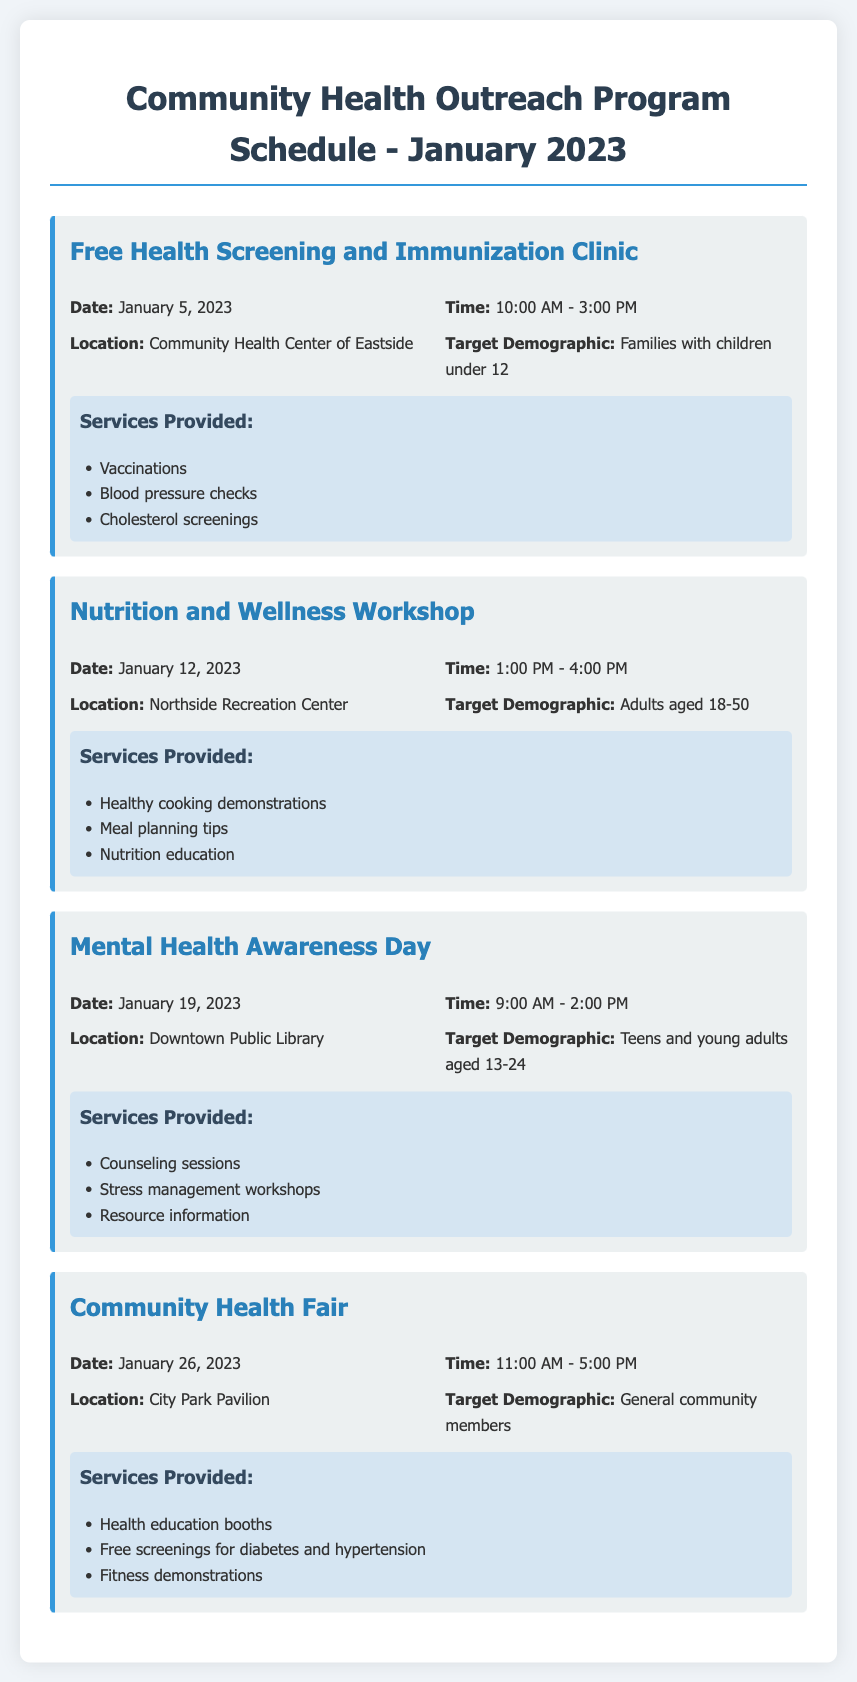What is the date of the Free Health Screening and Immunization Clinic? The date is mentioned in the schedule for the corresponding event, which is January 5, 2023.
Answer: January 5, 2023 What time does the Nutrition and Wellness Workshop start? The start time is specified under the event details for the Nutrition and Wellness Workshop, which is 1:00 PM.
Answer: 1:00 PM Where is the Mental Health Awareness Day being held? The location is provided in the event details, which states it will be at the Downtown Public Library.
Answer: Downtown Public Library Who is the target demographic for the Community Health Fair? The target demographic is specified in the event details, stated as general community members.
Answer: General community members What services are provided at the Free Health Screening and Immunization Clinic? The document lists the services offered under that event, including vaccinations, blood pressure checks, and cholesterol screenings.
Answer: Vaccinations, blood pressure checks, cholesterol screenings What is the duration of the Mental Health Awareness Day event? The duration of the event can be calculated from the start and end times provided, 9:00 AM to 2:00 PM, which is 5 hours.
Answer: 5 hours How many events are scheduled in January 2023? By counting the number of events listed in the agenda, we find four events scheduled.
Answer: Four What type of wellness is the workshop focused on? The type of focus is mentioned in the title and target audience of the event, indicating a focus on nutrition and wellness.
Answer: Nutrition and wellness 